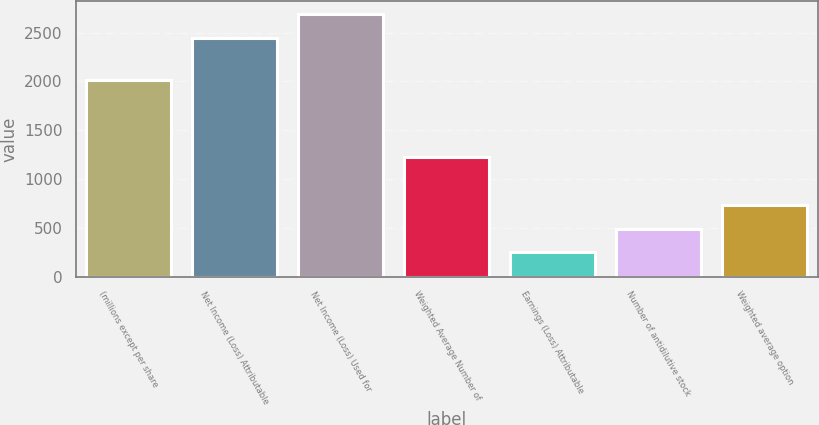<chart> <loc_0><loc_0><loc_500><loc_500><bar_chart><fcel>(millions except per share<fcel>Net Income (Loss) Attributable<fcel>Net Income (Loss) Used for<fcel>Weighted Average Number of<fcel>Earnings (Loss) Attributable<fcel>Number of antidilutive stock<fcel>Weighted average option<nl><fcel>2015<fcel>2441<fcel>2684.49<fcel>1223.52<fcel>249.56<fcel>493.05<fcel>736.54<nl></chart> 